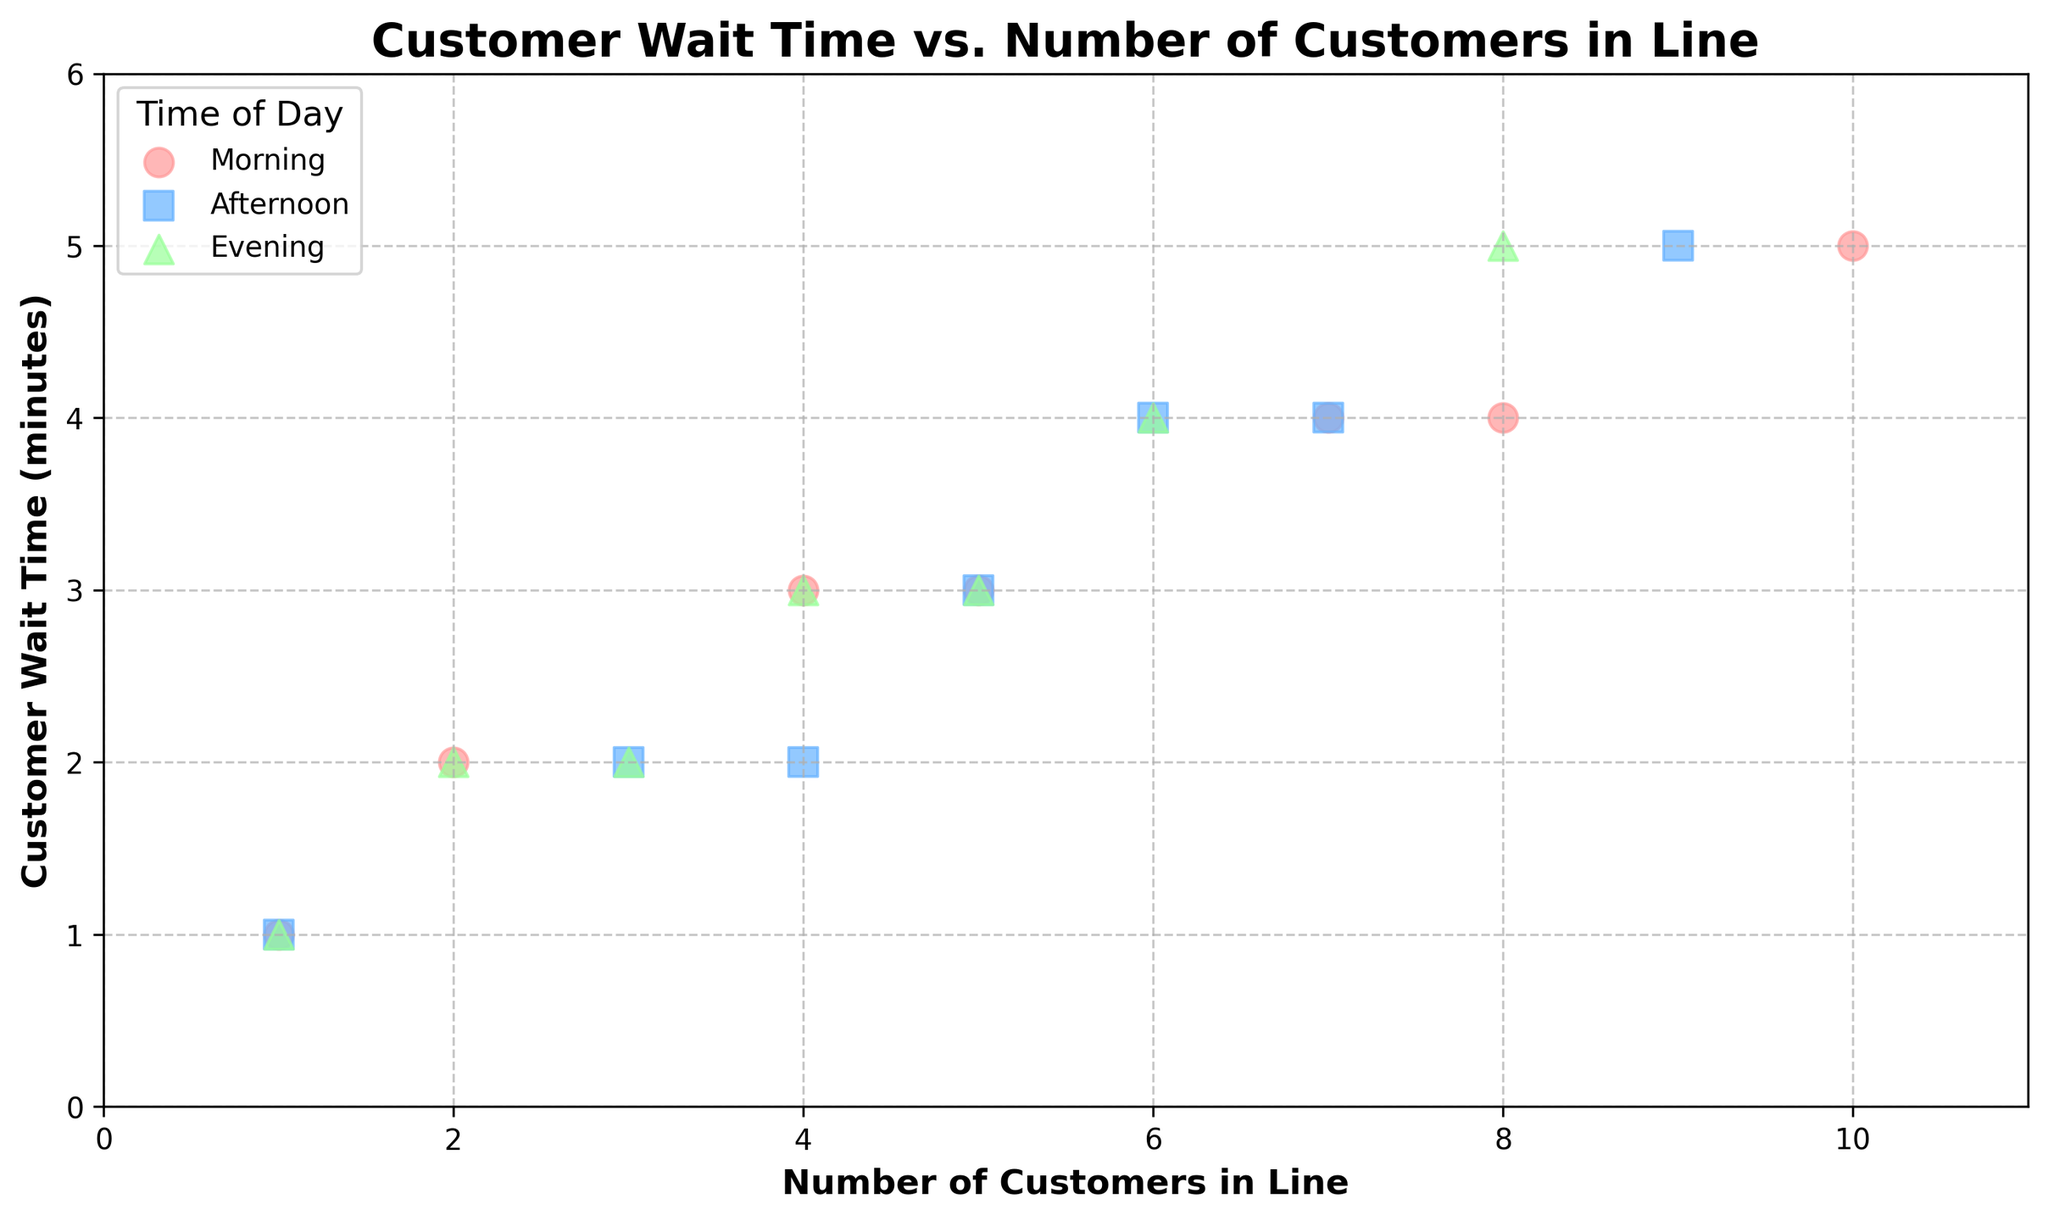What is the title of the plot? The title is displayed at the top of the plot.
Answer: Customer Wait Time vs. Number of Customers in Line What are the ranges for the x-axis and y-axis? The x-axis ranges from 0 to 11, and the y-axis ranges from 0 to 6, as shown by the axis labels and tick marks.
Answer: 0 to 11 for x-axis, 0 to 6 for y-axis What color represents the 'Afternoon' time of day? The scatter plot has three different colors representing three times of the day, and the legend shows 'Afternoon' is represented by blue.
Answer: Blue How many data points are shown in the 'Evening' group? By counting the number of markers corresponding to the 'Evening' group represented by green triangles, the plot shows 7 data points.
Answer: 7 Which time of day has the highest wait time for a single customer? By checking the y-axis values for all groups, the 'Evening' group has the highest wait time of 5 minutes for some points.
Answer: Evening What is the average wait time for customers in the 'Morning'? List the wait times for 'Morning': [1, 3, 5, 4, 2, 4, 3]. Calculate the average: (1+3+5+4+2+4+3)/7 = 3.14
Answer: 3.14 In which time of day do customers wait the longest on average when there are 4 customers in line? Look for data points where the x-axis is 4 for each time of day and compare the corresponding y values. The points are 3 (Morning), 2 (Afternoon), and 3 (Evening). Thus, both 'Morning' and 'Evening' have the longest average wait time when there are 4 customers.
Answer: Morning and Evening Is there any time of day where a waiting time of 6 minutes was recorded? Check all groups for the highest value on the y-axis; none of the markers reach a wait time of 6 minutes.
Answer: No Which time of day shows the most variability in customer wait times? Compare the y-axis ranges for each group. 'Morning' and 'Afternoon' span from 1 to 5 minutes, and 'Evening' also spans from 1 to 5 minutes. So all have similar variability.
Answer: All have similar variability 